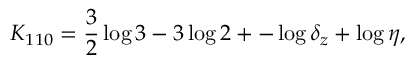<formula> <loc_0><loc_0><loc_500><loc_500>K _ { 1 1 0 } = \frac { 3 } { 2 } \log 3 - 3 \log 2 + - \log \delta _ { z } + \log \eta ,</formula> 